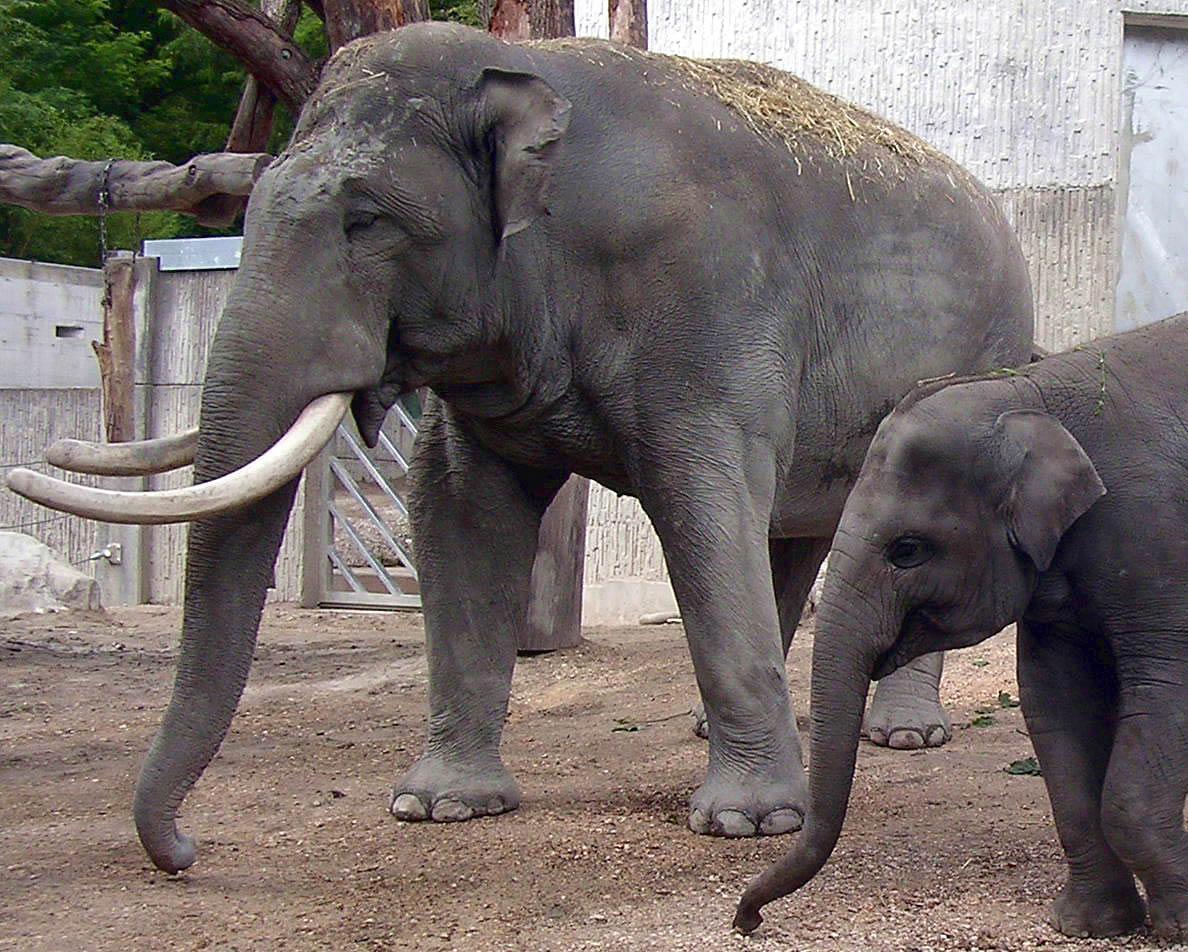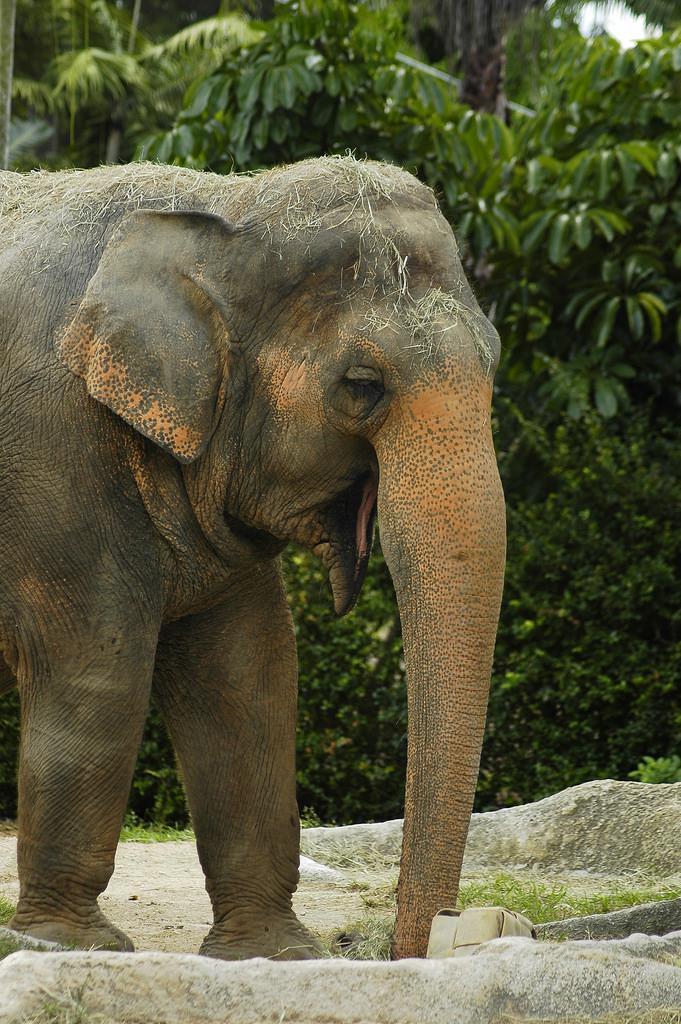The first image is the image on the left, the second image is the image on the right. For the images displayed, is the sentence "The elephant in the right image is walking towards the right." factually correct? Answer yes or no. Yes. The first image is the image on the left, the second image is the image on the right. Assess this claim about the two images: "The left image includes an elephant with tusks, but the right image contains only a tuskless elephant.". Correct or not? Answer yes or no. Yes. 